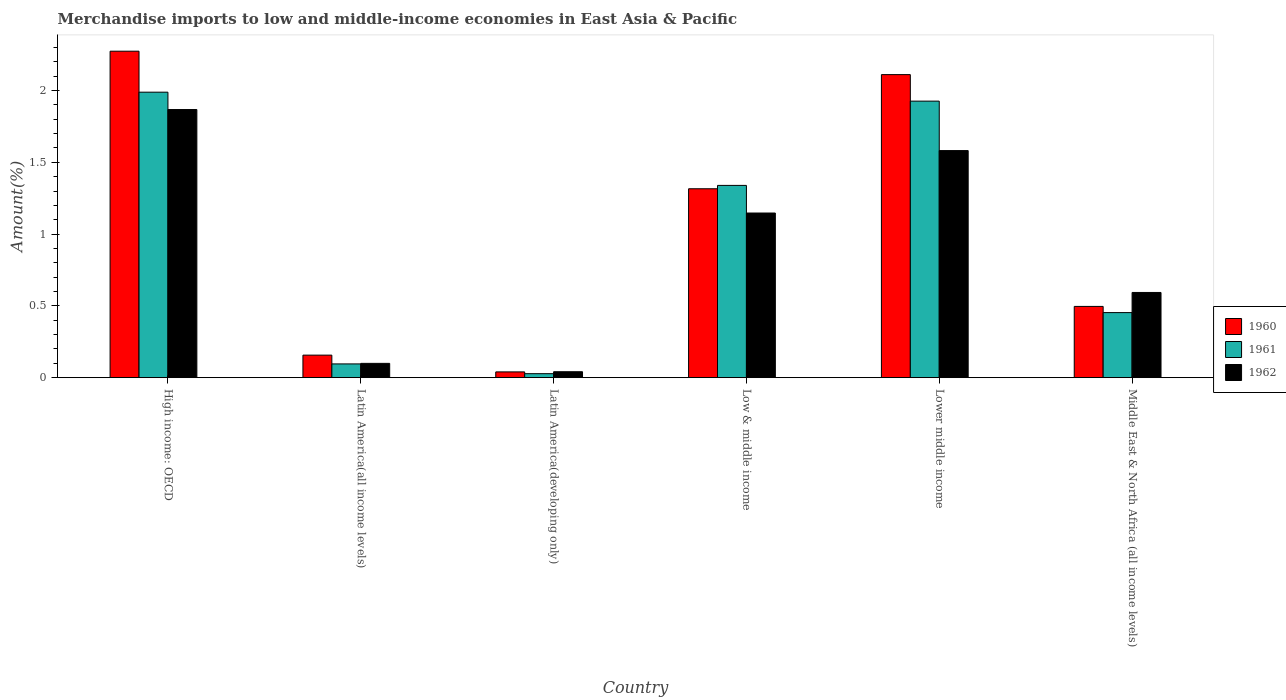How many groups of bars are there?
Offer a very short reply. 6. What is the label of the 2nd group of bars from the left?
Provide a short and direct response. Latin America(all income levels). What is the percentage of amount earned from merchandise imports in 1961 in Low & middle income?
Provide a short and direct response. 1.34. Across all countries, what is the maximum percentage of amount earned from merchandise imports in 1962?
Your answer should be very brief. 1.87. Across all countries, what is the minimum percentage of amount earned from merchandise imports in 1962?
Provide a succinct answer. 0.04. In which country was the percentage of amount earned from merchandise imports in 1962 maximum?
Your answer should be very brief. High income: OECD. In which country was the percentage of amount earned from merchandise imports in 1961 minimum?
Provide a succinct answer. Latin America(developing only). What is the total percentage of amount earned from merchandise imports in 1961 in the graph?
Offer a very short reply. 5.83. What is the difference between the percentage of amount earned from merchandise imports in 1962 in Latin America(all income levels) and that in Latin America(developing only)?
Your response must be concise. 0.06. What is the difference between the percentage of amount earned from merchandise imports in 1961 in Middle East & North Africa (all income levels) and the percentage of amount earned from merchandise imports in 1962 in Latin America(all income levels)?
Give a very brief answer. 0.35. What is the average percentage of amount earned from merchandise imports in 1960 per country?
Offer a terse response. 1.07. What is the difference between the percentage of amount earned from merchandise imports of/in 1962 and percentage of amount earned from merchandise imports of/in 1960 in High income: OECD?
Make the answer very short. -0.41. In how many countries, is the percentage of amount earned from merchandise imports in 1962 greater than 1.6 %?
Give a very brief answer. 1. What is the ratio of the percentage of amount earned from merchandise imports in 1961 in Latin America(developing only) to that in Middle East & North Africa (all income levels)?
Offer a terse response. 0.06. Is the percentage of amount earned from merchandise imports in 1961 in Latin America(all income levels) less than that in Middle East & North Africa (all income levels)?
Your response must be concise. Yes. What is the difference between the highest and the second highest percentage of amount earned from merchandise imports in 1961?
Keep it short and to the point. 0.65. What is the difference between the highest and the lowest percentage of amount earned from merchandise imports in 1960?
Offer a very short reply. 2.23. In how many countries, is the percentage of amount earned from merchandise imports in 1960 greater than the average percentage of amount earned from merchandise imports in 1960 taken over all countries?
Give a very brief answer. 3. Is it the case that in every country, the sum of the percentage of amount earned from merchandise imports in 1961 and percentage of amount earned from merchandise imports in 1962 is greater than the percentage of amount earned from merchandise imports in 1960?
Keep it short and to the point. Yes. How many bars are there?
Offer a very short reply. 18. Are all the bars in the graph horizontal?
Keep it short and to the point. No. How many countries are there in the graph?
Give a very brief answer. 6. What is the difference between two consecutive major ticks on the Y-axis?
Your response must be concise. 0.5. Does the graph contain any zero values?
Provide a short and direct response. No. Does the graph contain grids?
Offer a very short reply. No. Where does the legend appear in the graph?
Provide a succinct answer. Center right. How are the legend labels stacked?
Provide a short and direct response. Vertical. What is the title of the graph?
Keep it short and to the point. Merchandise imports to low and middle-income economies in East Asia & Pacific. Does "1982" appear as one of the legend labels in the graph?
Offer a very short reply. No. What is the label or title of the X-axis?
Your response must be concise. Country. What is the label or title of the Y-axis?
Offer a terse response. Amount(%). What is the Amount(%) of 1960 in High income: OECD?
Make the answer very short. 2.27. What is the Amount(%) in 1961 in High income: OECD?
Your answer should be very brief. 1.99. What is the Amount(%) of 1962 in High income: OECD?
Your answer should be compact. 1.87. What is the Amount(%) in 1960 in Latin America(all income levels)?
Ensure brevity in your answer.  0.16. What is the Amount(%) of 1961 in Latin America(all income levels)?
Make the answer very short. 0.1. What is the Amount(%) in 1962 in Latin America(all income levels)?
Your response must be concise. 0.1. What is the Amount(%) of 1960 in Latin America(developing only)?
Ensure brevity in your answer.  0.04. What is the Amount(%) in 1961 in Latin America(developing only)?
Make the answer very short. 0.03. What is the Amount(%) in 1962 in Latin America(developing only)?
Make the answer very short. 0.04. What is the Amount(%) of 1960 in Low & middle income?
Your answer should be very brief. 1.32. What is the Amount(%) in 1961 in Low & middle income?
Your response must be concise. 1.34. What is the Amount(%) in 1962 in Low & middle income?
Offer a terse response. 1.15. What is the Amount(%) in 1960 in Lower middle income?
Your answer should be compact. 2.11. What is the Amount(%) of 1961 in Lower middle income?
Make the answer very short. 1.93. What is the Amount(%) of 1962 in Lower middle income?
Your response must be concise. 1.58. What is the Amount(%) of 1960 in Middle East & North Africa (all income levels)?
Ensure brevity in your answer.  0.5. What is the Amount(%) in 1961 in Middle East & North Africa (all income levels)?
Your response must be concise. 0.45. What is the Amount(%) of 1962 in Middle East & North Africa (all income levels)?
Offer a very short reply. 0.59. Across all countries, what is the maximum Amount(%) in 1960?
Give a very brief answer. 2.27. Across all countries, what is the maximum Amount(%) in 1961?
Make the answer very short. 1.99. Across all countries, what is the maximum Amount(%) in 1962?
Your response must be concise. 1.87. Across all countries, what is the minimum Amount(%) in 1960?
Offer a terse response. 0.04. Across all countries, what is the minimum Amount(%) of 1961?
Provide a succinct answer. 0.03. Across all countries, what is the minimum Amount(%) of 1962?
Give a very brief answer. 0.04. What is the total Amount(%) in 1960 in the graph?
Offer a very short reply. 6.39. What is the total Amount(%) of 1961 in the graph?
Give a very brief answer. 5.83. What is the total Amount(%) in 1962 in the graph?
Provide a succinct answer. 5.33. What is the difference between the Amount(%) of 1960 in High income: OECD and that in Latin America(all income levels)?
Make the answer very short. 2.12. What is the difference between the Amount(%) in 1961 in High income: OECD and that in Latin America(all income levels)?
Offer a terse response. 1.89. What is the difference between the Amount(%) of 1962 in High income: OECD and that in Latin America(all income levels)?
Your response must be concise. 1.77. What is the difference between the Amount(%) of 1960 in High income: OECD and that in Latin America(developing only)?
Provide a succinct answer. 2.23. What is the difference between the Amount(%) in 1961 in High income: OECD and that in Latin America(developing only)?
Your answer should be very brief. 1.96. What is the difference between the Amount(%) in 1962 in High income: OECD and that in Latin America(developing only)?
Offer a terse response. 1.83. What is the difference between the Amount(%) of 1960 in High income: OECD and that in Low & middle income?
Make the answer very short. 0.96. What is the difference between the Amount(%) in 1961 in High income: OECD and that in Low & middle income?
Ensure brevity in your answer.  0.65. What is the difference between the Amount(%) in 1962 in High income: OECD and that in Low & middle income?
Your response must be concise. 0.72. What is the difference between the Amount(%) of 1960 in High income: OECD and that in Lower middle income?
Offer a very short reply. 0.16. What is the difference between the Amount(%) of 1961 in High income: OECD and that in Lower middle income?
Provide a succinct answer. 0.06. What is the difference between the Amount(%) of 1962 in High income: OECD and that in Lower middle income?
Your response must be concise. 0.29. What is the difference between the Amount(%) in 1960 in High income: OECD and that in Middle East & North Africa (all income levels)?
Your answer should be compact. 1.78. What is the difference between the Amount(%) of 1961 in High income: OECD and that in Middle East & North Africa (all income levels)?
Keep it short and to the point. 1.54. What is the difference between the Amount(%) of 1962 in High income: OECD and that in Middle East & North Africa (all income levels)?
Provide a short and direct response. 1.27. What is the difference between the Amount(%) of 1960 in Latin America(all income levels) and that in Latin America(developing only)?
Offer a very short reply. 0.12. What is the difference between the Amount(%) in 1961 in Latin America(all income levels) and that in Latin America(developing only)?
Your answer should be compact. 0.07. What is the difference between the Amount(%) in 1962 in Latin America(all income levels) and that in Latin America(developing only)?
Your response must be concise. 0.06. What is the difference between the Amount(%) in 1960 in Latin America(all income levels) and that in Low & middle income?
Make the answer very short. -1.16. What is the difference between the Amount(%) of 1961 in Latin America(all income levels) and that in Low & middle income?
Your answer should be very brief. -1.24. What is the difference between the Amount(%) of 1962 in Latin America(all income levels) and that in Low & middle income?
Provide a succinct answer. -1.05. What is the difference between the Amount(%) of 1960 in Latin America(all income levels) and that in Lower middle income?
Provide a succinct answer. -1.95. What is the difference between the Amount(%) of 1961 in Latin America(all income levels) and that in Lower middle income?
Your answer should be compact. -1.83. What is the difference between the Amount(%) in 1962 in Latin America(all income levels) and that in Lower middle income?
Give a very brief answer. -1.48. What is the difference between the Amount(%) of 1960 in Latin America(all income levels) and that in Middle East & North Africa (all income levels)?
Your response must be concise. -0.34. What is the difference between the Amount(%) in 1961 in Latin America(all income levels) and that in Middle East & North Africa (all income levels)?
Your response must be concise. -0.36. What is the difference between the Amount(%) in 1962 in Latin America(all income levels) and that in Middle East & North Africa (all income levels)?
Your answer should be compact. -0.49. What is the difference between the Amount(%) of 1960 in Latin America(developing only) and that in Low & middle income?
Provide a succinct answer. -1.28. What is the difference between the Amount(%) of 1961 in Latin America(developing only) and that in Low & middle income?
Your answer should be very brief. -1.31. What is the difference between the Amount(%) of 1962 in Latin America(developing only) and that in Low & middle income?
Make the answer very short. -1.11. What is the difference between the Amount(%) of 1960 in Latin America(developing only) and that in Lower middle income?
Offer a very short reply. -2.07. What is the difference between the Amount(%) in 1961 in Latin America(developing only) and that in Lower middle income?
Your answer should be compact. -1.9. What is the difference between the Amount(%) of 1962 in Latin America(developing only) and that in Lower middle income?
Your answer should be compact. -1.54. What is the difference between the Amount(%) in 1960 in Latin America(developing only) and that in Middle East & North Africa (all income levels)?
Your response must be concise. -0.46. What is the difference between the Amount(%) of 1961 in Latin America(developing only) and that in Middle East & North Africa (all income levels)?
Your response must be concise. -0.43. What is the difference between the Amount(%) in 1962 in Latin America(developing only) and that in Middle East & North Africa (all income levels)?
Provide a succinct answer. -0.55. What is the difference between the Amount(%) of 1960 in Low & middle income and that in Lower middle income?
Make the answer very short. -0.8. What is the difference between the Amount(%) of 1961 in Low & middle income and that in Lower middle income?
Offer a very short reply. -0.59. What is the difference between the Amount(%) in 1962 in Low & middle income and that in Lower middle income?
Make the answer very short. -0.43. What is the difference between the Amount(%) of 1960 in Low & middle income and that in Middle East & North Africa (all income levels)?
Offer a terse response. 0.82. What is the difference between the Amount(%) in 1961 in Low & middle income and that in Middle East & North Africa (all income levels)?
Keep it short and to the point. 0.89. What is the difference between the Amount(%) of 1962 in Low & middle income and that in Middle East & North Africa (all income levels)?
Your answer should be very brief. 0.55. What is the difference between the Amount(%) of 1960 in Lower middle income and that in Middle East & North Africa (all income levels)?
Provide a succinct answer. 1.61. What is the difference between the Amount(%) of 1961 in Lower middle income and that in Middle East & North Africa (all income levels)?
Offer a very short reply. 1.47. What is the difference between the Amount(%) of 1962 in Lower middle income and that in Middle East & North Africa (all income levels)?
Keep it short and to the point. 0.99. What is the difference between the Amount(%) of 1960 in High income: OECD and the Amount(%) of 1961 in Latin America(all income levels)?
Your answer should be very brief. 2.18. What is the difference between the Amount(%) of 1960 in High income: OECD and the Amount(%) of 1962 in Latin America(all income levels)?
Your answer should be compact. 2.17. What is the difference between the Amount(%) of 1961 in High income: OECD and the Amount(%) of 1962 in Latin America(all income levels)?
Ensure brevity in your answer.  1.89. What is the difference between the Amount(%) of 1960 in High income: OECD and the Amount(%) of 1961 in Latin America(developing only)?
Your answer should be very brief. 2.25. What is the difference between the Amount(%) of 1960 in High income: OECD and the Amount(%) of 1962 in Latin America(developing only)?
Your answer should be compact. 2.23. What is the difference between the Amount(%) of 1961 in High income: OECD and the Amount(%) of 1962 in Latin America(developing only)?
Your response must be concise. 1.95. What is the difference between the Amount(%) of 1960 in High income: OECD and the Amount(%) of 1961 in Low & middle income?
Your answer should be very brief. 0.93. What is the difference between the Amount(%) of 1960 in High income: OECD and the Amount(%) of 1962 in Low & middle income?
Offer a very short reply. 1.13. What is the difference between the Amount(%) in 1961 in High income: OECD and the Amount(%) in 1962 in Low & middle income?
Your answer should be very brief. 0.84. What is the difference between the Amount(%) in 1960 in High income: OECD and the Amount(%) in 1961 in Lower middle income?
Give a very brief answer. 0.35. What is the difference between the Amount(%) of 1960 in High income: OECD and the Amount(%) of 1962 in Lower middle income?
Your response must be concise. 0.69. What is the difference between the Amount(%) in 1961 in High income: OECD and the Amount(%) in 1962 in Lower middle income?
Give a very brief answer. 0.41. What is the difference between the Amount(%) of 1960 in High income: OECD and the Amount(%) of 1961 in Middle East & North Africa (all income levels)?
Keep it short and to the point. 1.82. What is the difference between the Amount(%) in 1960 in High income: OECD and the Amount(%) in 1962 in Middle East & North Africa (all income levels)?
Ensure brevity in your answer.  1.68. What is the difference between the Amount(%) of 1961 in High income: OECD and the Amount(%) of 1962 in Middle East & North Africa (all income levels)?
Your answer should be very brief. 1.4. What is the difference between the Amount(%) of 1960 in Latin America(all income levels) and the Amount(%) of 1961 in Latin America(developing only)?
Give a very brief answer. 0.13. What is the difference between the Amount(%) in 1960 in Latin America(all income levels) and the Amount(%) in 1962 in Latin America(developing only)?
Ensure brevity in your answer.  0.12. What is the difference between the Amount(%) in 1961 in Latin America(all income levels) and the Amount(%) in 1962 in Latin America(developing only)?
Your response must be concise. 0.05. What is the difference between the Amount(%) of 1960 in Latin America(all income levels) and the Amount(%) of 1961 in Low & middle income?
Provide a short and direct response. -1.18. What is the difference between the Amount(%) in 1960 in Latin America(all income levels) and the Amount(%) in 1962 in Low & middle income?
Provide a succinct answer. -0.99. What is the difference between the Amount(%) in 1961 in Latin America(all income levels) and the Amount(%) in 1962 in Low & middle income?
Ensure brevity in your answer.  -1.05. What is the difference between the Amount(%) in 1960 in Latin America(all income levels) and the Amount(%) in 1961 in Lower middle income?
Your answer should be compact. -1.77. What is the difference between the Amount(%) of 1960 in Latin America(all income levels) and the Amount(%) of 1962 in Lower middle income?
Provide a short and direct response. -1.42. What is the difference between the Amount(%) in 1961 in Latin America(all income levels) and the Amount(%) in 1962 in Lower middle income?
Provide a short and direct response. -1.49. What is the difference between the Amount(%) in 1960 in Latin America(all income levels) and the Amount(%) in 1961 in Middle East & North Africa (all income levels)?
Provide a short and direct response. -0.3. What is the difference between the Amount(%) of 1960 in Latin America(all income levels) and the Amount(%) of 1962 in Middle East & North Africa (all income levels)?
Give a very brief answer. -0.44. What is the difference between the Amount(%) in 1961 in Latin America(all income levels) and the Amount(%) in 1962 in Middle East & North Africa (all income levels)?
Make the answer very short. -0.5. What is the difference between the Amount(%) in 1960 in Latin America(developing only) and the Amount(%) in 1961 in Low & middle income?
Ensure brevity in your answer.  -1.3. What is the difference between the Amount(%) in 1960 in Latin America(developing only) and the Amount(%) in 1962 in Low & middle income?
Give a very brief answer. -1.11. What is the difference between the Amount(%) of 1961 in Latin America(developing only) and the Amount(%) of 1962 in Low & middle income?
Your response must be concise. -1.12. What is the difference between the Amount(%) of 1960 in Latin America(developing only) and the Amount(%) of 1961 in Lower middle income?
Your answer should be very brief. -1.89. What is the difference between the Amount(%) of 1960 in Latin America(developing only) and the Amount(%) of 1962 in Lower middle income?
Keep it short and to the point. -1.54. What is the difference between the Amount(%) in 1961 in Latin America(developing only) and the Amount(%) in 1962 in Lower middle income?
Make the answer very short. -1.55. What is the difference between the Amount(%) of 1960 in Latin America(developing only) and the Amount(%) of 1961 in Middle East & North Africa (all income levels)?
Your response must be concise. -0.41. What is the difference between the Amount(%) in 1960 in Latin America(developing only) and the Amount(%) in 1962 in Middle East & North Africa (all income levels)?
Your answer should be compact. -0.55. What is the difference between the Amount(%) of 1961 in Latin America(developing only) and the Amount(%) of 1962 in Middle East & North Africa (all income levels)?
Offer a very short reply. -0.57. What is the difference between the Amount(%) of 1960 in Low & middle income and the Amount(%) of 1961 in Lower middle income?
Your answer should be compact. -0.61. What is the difference between the Amount(%) of 1960 in Low & middle income and the Amount(%) of 1962 in Lower middle income?
Give a very brief answer. -0.27. What is the difference between the Amount(%) of 1961 in Low & middle income and the Amount(%) of 1962 in Lower middle income?
Make the answer very short. -0.24. What is the difference between the Amount(%) of 1960 in Low & middle income and the Amount(%) of 1961 in Middle East & North Africa (all income levels)?
Offer a very short reply. 0.86. What is the difference between the Amount(%) of 1960 in Low & middle income and the Amount(%) of 1962 in Middle East & North Africa (all income levels)?
Keep it short and to the point. 0.72. What is the difference between the Amount(%) in 1961 in Low & middle income and the Amount(%) in 1962 in Middle East & North Africa (all income levels)?
Offer a terse response. 0.75. What is the difference between the Amount(%) of 1960 in Lower middle income and the Amount(%) of 1961 in Middle East & North Africa (all income levels)?
Your answer should be compact. 1.66. What is the difference between the Amount(%) of 1960 in Lower middle income and the Amount(%) of 1962 in Middle East & North Africa (all income levels)?
Offer a very short reply. 1.52. What is the difference between the Amount(%) of 1961 in Lower middle income and the Amount(%) of 1962 in Middle East & North Africa (all income levels)?
Your response must be concise. 1.33. What is the average Amount(%) in 1960 per country?
Provide a short and direct response. 1.07. What is the average Amount(%) of 1961 per country?
Your answer should be compact. 0.97. What is the average Amount(%) in 1962 per country?
Offer a terse response. 0.89. What is the difference between the Amount(%) in 1960 and Amount(%) in 1961 in High income: OECD?
Keep it short and to the point. 0.29. What is the difference between the Amount(%) of 1960 and Amount(%) of 1962 in High income: OECD?
Offer a very short reply. 0.41. What is the difference between the Amount(%) in 1961 and Amount(%) in 1962 in High income: OECD?
Give a very brief answer. 0.12. What is the difference between the Amount(%) in 1960 and Amount(%) in 1961 in Latin America(all income levels)?
Your answer should be compact. 0.06. What is the difference between the Amount(%) of 1960 and Amount(%) of 1962 in Latin America(all income levels)?
Provide a short and direct response. 0.06. What is the difference between the Amount(%) of 1961 and Amount(%) of 1962 in Latin America(all income levels)?
Offer a very short reply. -0. What is the difference between the Amount(%) of 1960 and Amount(%) of 1961 in Latin America(developing only)?
Your response must be concise. 0.01. What is the difference between the Amount(%) of 1960 and Amount(%) of 1962 in Latin America(developing only)?
Ensure brevity in your answer.  -0. What is the difference between the Amount(%) in 1961 and Amount(%) in 1962 in Latin America(developing only)?
Provide a short and direct response. -0.01. What is the difference between the Amount(%) of 1960 and Amount(%) of 1961 in Low & middle income?
Keep it short and to the point. -0.02. What is the difference between the Amount(%) in 1960 and Amount(%) in 1962 in Low & middle income?
Keep it short and to the point. 0.17. What is the difference between the Amount(%) of 1961 and Amount(%) of 1962 in Low & middle income?
Give a very brief answer. 0.19. What is the difference between the Amount(%) of 1960 and Amount(%) of 1961 in Lower middle income?
Ensure brevity in your answer.  0.18. What is the difference between the Amount(%) in 1960 and Amount(%) in 1962 in Lower middle income?
Your answer should be compact. 0.53. What is the difference between the Amount(%) of 1961 and Amount(%) of 1962 in Lower middle income?
Keep it short and to the point. 0.34. What is the difference between the Amount(%) in 1960 and Amount(%) in 1961 in Middle East & North Africa (all income levels)?
Keep it short and to the point. 0.04. What is the difference between the Amount(%) of 1960 and Amount(%) of 1962 in Middle East & North Africa (all income levels)?
Ensure brevity in your answer.  -0.1. What is the difference between the Amount(%) of 1961 and Amount(%) of 1962 in Middle East & North Africa (all income levels)?
Your answer should be compact. -0.14. What is the ratio of the Amount(%) of 1960 in High income: OECD to that in Latin America(all income levels)?
Keep it short and to the point. 14.49. What is the ratio of the Amount(%) of 1961 in High income: OECD to that in Latin America(all income levels)?
Your answer should be compact. 20.76. What is the ratio of the Amount(%) in 1962 in High income: OECD to that in Latin America(all income levels)?
Your answer should be very brief. 18.75. What is the ratio of the Amount(%) in 1960 in High income: OECD to that in Latin America(developing only)?
Keep it short and to the point. 56.7. What is the ratio of the Amount(%) of 1961 in High income: OECD to that in Latin America(developing only)?
Offer a terse response. 71.56. What is the ratio of the Amount(%) of 1962 in High income: OECD to that in Latin America(developing only)?
Offer a terse response. 45.19. What is the ratio of the Amount(%) of 1960 in High income: OECD to that in Low & middle income?
Your response must be concise. 1.73. What is the ratio of the Amount(%) of 1961 in High income: OECD to that in Low & middle income?
Your answer should be very brief. 1.48. What is the ratio of the Amount(%) of 1962 in High income: OECD to that in Low & middle income?
Offer a very short reply. 1.63. What is the ratio of the Amount(%) in 1960 in High income: OECD to that in Lower middle income?
Keep it short and to the point. 1.08. What is the ratio of the Amount(%) of 1961 in High income: OECD to that in Lower middle income?
Your answer should be very brief. 1.03. What is the ratio of the Amount(%) of 1962 in High income: OECD to that in Lower middle income?
Offer a terse response. 1.18. What is the ratio of the Amount(%) of 1960 in High income: OECD to that in Middle East & North Africa (all income levels)?
Keep it short and to the point. 4.58. What is the ratio of the Amount(%) of 1961 in High income: OECD to that in Middle East & North Africa (all income levels)?
Ensure brevity in your answer.  4.39. What is the ratio of the Amount(%) in 1962 in High income: OECD to that in Middle East & North Africa (all income levels)?
Offer a terse response. 3.15. What is the ratio of the Amount(%) of 1960 in Latin America(all income levels) to that in Latin America(developing only)?
Give a very brief answer. 3.91. What is the ratio of the Amount(%) of 1961 in Latin America(all income levels) to that in Latin America(developing only)?
Your response must be concise. 3.45. What is the ratio of the Amount(%) of 1962 in Latin America(all income levels) to that in Latin America(developing only)?
Make the answer very short. 2.41. What is the ratio of the Amount(%) in 1960 in Latin America(all income levels) to that in Low & middle income?
Your answer should be very brief. 0.12. What is the ratio of the Amount(%) in 1961 in Latin America(all income levels) to that in Low & middle income?
Offer a terse response. 0.07. What is the ratio of the Amount(%) in 1962 in Latin America(all income levels) to that in Low & middle income?
Ensure brevity in your answer.  0.09. What is the ratio of the Amount(%) of 1960 in Latin America(all income levels) to that in Lower middle income?
Keep it short and to the point. 0.07. What is the ratio of the Amount(%) of 1961 in Latin America(all income levels) to that in Lower middle income?
Your response must be concise. 0.05. What is the ratio of the Amount(%) of 1962 in Latin America(all income levels) to that in Lower middle income?
Your answer should be very brief. 0.06. What is the ratio of the Amount(%) of 1960 in Latin America(all income levels) to that in Middle East & North Africa (all income levels)?
Ensure brevity in your answer.  0.32. What is the ratio of the Amount(%) in 1961 in Latin America(all income levels) to that in Middle East & North Africa (all income levels)?
Offer a very short reply. 0.21. What is the ratio of the Amount(%) in 1962 in Latin America(all income levels) to that in Middle East & North Africa (all income levels)?
Your response must be concise. 0.17. What is the ratio of the Amount(%) in 1960 in Latin America(developing only) to that in Low & middle income?
Give a very brief answer. 0.03. What is the ratio of the Amount(%) in 1961 in Latin America(developing only) to that in Low & middle income?
Your answer should be very brief. 0.02. What is the ratio of the Amount(%) of 1962 in Latin America(developing only) to that in Low & middle income?
Provide a succinct answer. 0.04. What is the ratio of the Amount(%) in 1960 in Latin America(developing only) to that in Lower middle income?
Offer a very short reply. 0.02. What is the ratio of the Amount(%) in 1961 in Latin America(developing only) to that in Lower middle income?
Your answer should be compact. 0.01. What is the ratio of the Amount(%) of 1962 in Latin America(developing only) to that in Lower middle income?
Ensure brevity in your answer.  0.03. What is the ratio of the Amount(%) in 1960 in Latin America(developing only) to that in Middle East & North Africa (all income levels)?
Provide a short and direct response. 0.08. What is the ratio of the Amount(%) in 1961 in Latin America(developing only) to that in Middle East & North Africa (all income levels)?
Provide a short and direct response. 0.06. What is the ratio of the Amount(%) in 1962 in Latin America(developing only) to that in Middle East & North Africa (all income levels)?
Offer a terse response. 0.07. What is the ratio of the Amount(%) of 1960 in Low & middle income to that in Lower middle income?
Give a very brief answer. 0.62. What is the ratio of the Amount(%) in 1961 in Low & middle income to that in Lower middle income?
Give a very brief answer. 0.7. What is the ratio of the Amount(%) of 1962 in Low & middle income to that in Lower middle income?
Your answer should be very brief. 0.73. What is the ratio of the Amount(%) of 1960 in Low & middle income to that in Middle East & North Africa (all income levels)?
Your response must be concise. 2.65. What is the ratio of the Amount(%) of 1961 in Low & middle income to that in Middle East & North Africa (all income levels)?
Give a very brief answer. 2.96. What is the ratio of the Amount(%) of 1962 in Low & middle income to that in Middle East & North Africa (all income levels)?
Keep it short and to the point. 1.93. What is the ratio of the Amount(%) of 1960 in Lower middle income to that in Middle East & North Africa (all income levels)?
Your answer should be compact. 4.25. What is the ratio of the Amount(%) in 1961 in Lower middle income to that in Middle East & North Africa (all income levels)?
Ensure brevity in your answer.  4.25. What is the ratio of the Amount(%) of 1962 in Lower middle income to that in Middle East & North Africa (all income levels)?
Your response must be concise. 2.67. What is the difference between the highest and the second highest Amount(%) in 1960?
Make the answer very short. 0.16. What is the difference between the highest and the second highest Amount(%) of 1961?
Give a very brief answer. 0.06. What is the difference between the highest and the second highest Amount(%) in 1962?
Your answer should be compact. 0.29. What is the difference between the highest and the lowest Amount(%) in 1960?
Ensure brevity in your answer.  2.23. What is the difference between the highest and the lowest Amount(%) of 1961?
Make the answer very short. 1.96. What is the difference between the highest and the lowest Amount(%) of 1962?
Your response must be concise. 1.83. 